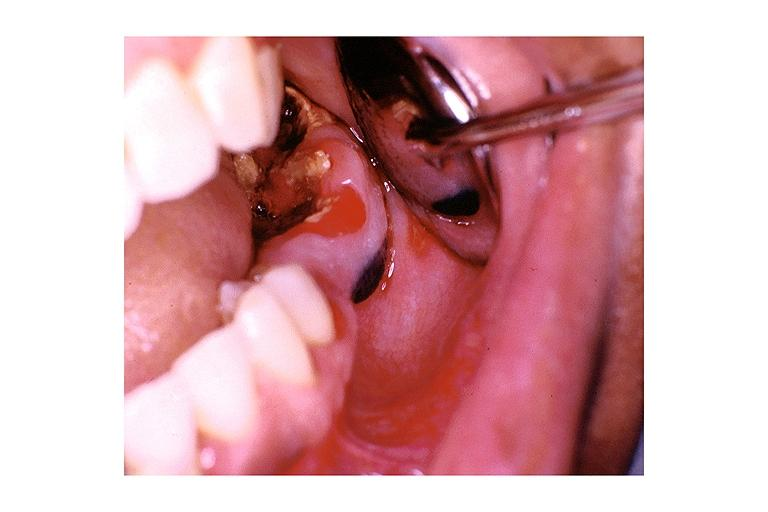does this image show nevus?
Answer the question using a single word or phrase. Yes 